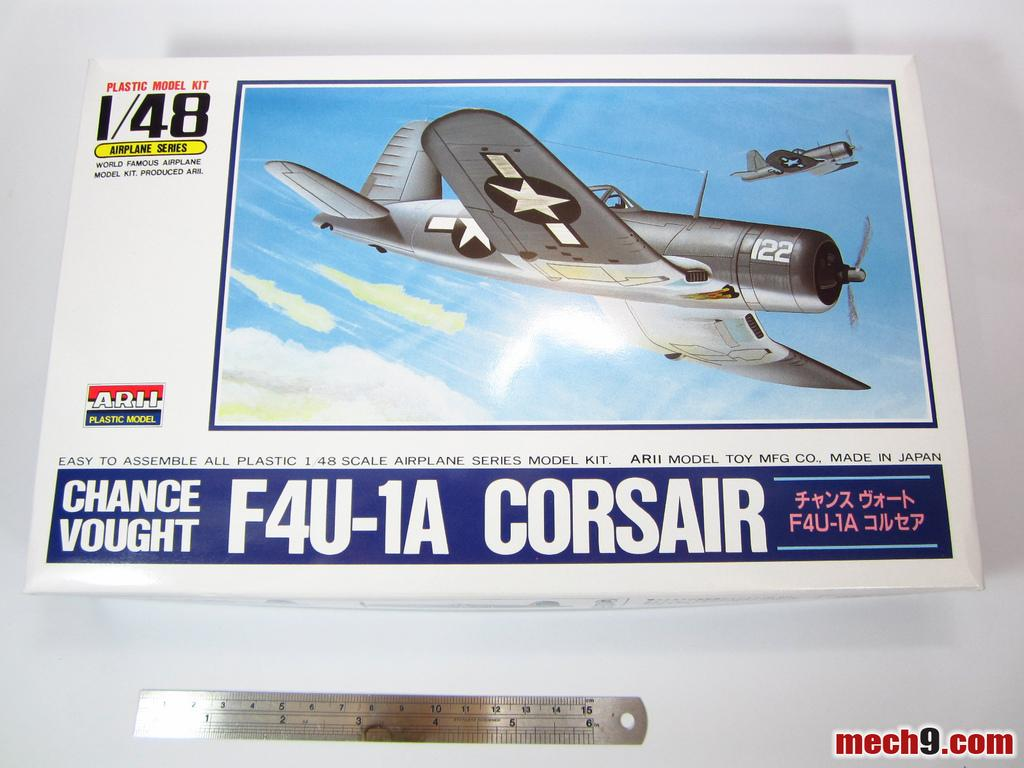Provide a one-sentence caption for the provided image. An airplane model for an F4U-1A Corsair is made in Japan. 